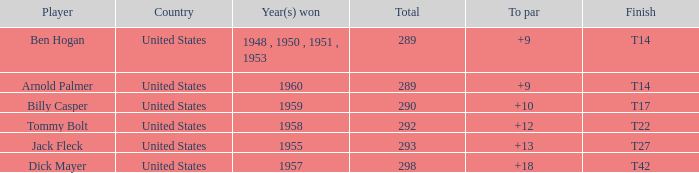What is Player, when Year(s) Won is 1955? Jack Fleck. 